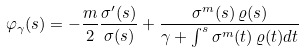<formula> <loc_0><loc_0><loc_500><loc_500>\varphi _ { \gamma } ( s ) = - \frac { m } { 2 } \frac { \sigma ^ { \prime } ( s ) } { \sigma ( s ) } + \frac { \sigma ^ { m } ( s ) \, \varrho ( s ) } { \gamma + \int ^ { s } \sigma ^ { m } ( t ) \, \varrho ( t ) d t }</formula> 